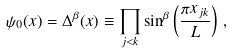Convert formula to latex. <formula><loc_0><loc_0><loc_500><loc_500>\psi _ { 0 } ( x ) = \Delta ^ { \beta } ( x ) \equiv \prod _ { j < k } \sin ^ { \beta } \left ( \frac { \pi x _ { j k } } { L } \right ) \, ,</formula> 